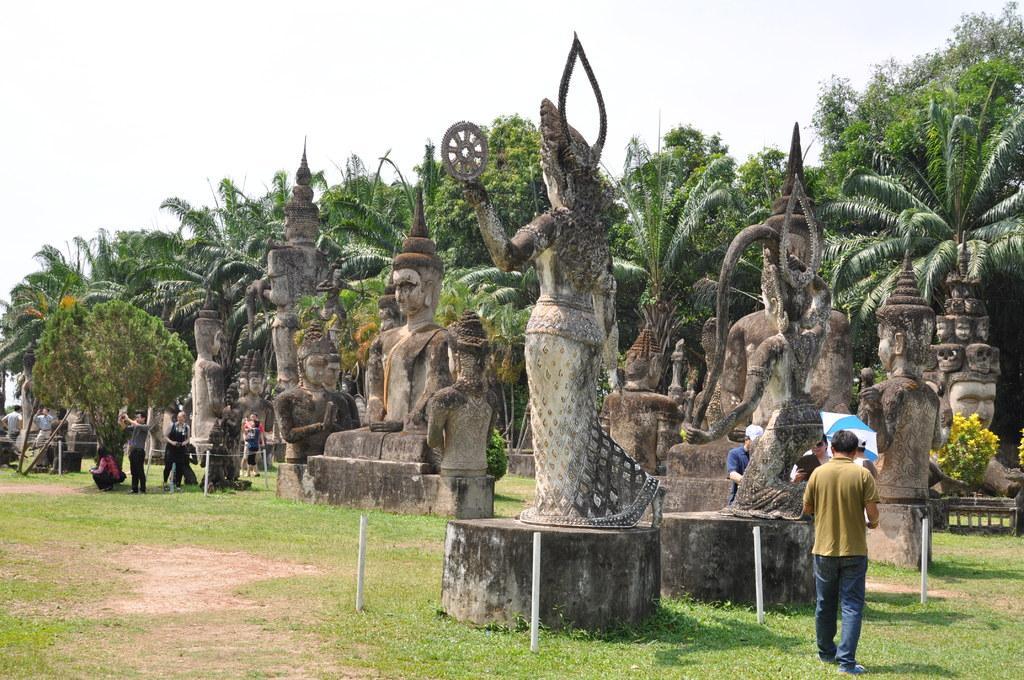How would you summarize this image in a sentence or two? In this image we can see few statues and people standing on the ground, there are few rods, an umbrella and there are few trees and the sky in the background. 